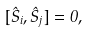<formula> <loc_0><loc_0><loc_500><loc_500>[ \hat { S } _ { i } , \hat { S } _ { j } ] = 0 ,</formula> 